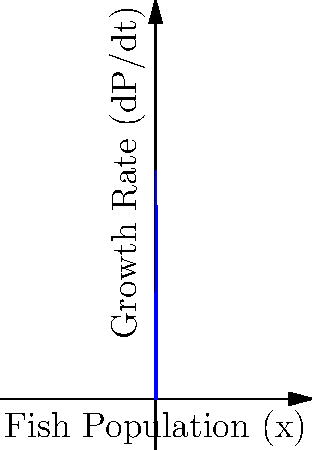A marine ecosystem follows a logistic growth model for its fish population, described by the differential equation:

$$\frac{dP}{dt} = rP(1-\frac{P}{K})$$

where $P$ is the population size, $r$ is the growth rate, and $K$ is the carrying capacity. Given $r = 0.4$ and $K = 5000$, at what population size will the growth rate be maximized? How can this information be used to determine a sustainable fishing quota? To solve this problem, we'll follow these steps:

1) The growth rate (dP/dt) is maximized when the population is at half the carrying capacity. This occurs at the vertex of the parabola in the logistic growth curve.

2) Mathematically, we can find this point by setting $P = \frac{K}{2}$:

   $P = \frac{K}{2} = \frac{5000}{2} = 2500$

3) To verify, we can calculate the second derivative of the growth equation and show it's negative at this point, confirming a maximum:

   $$\frac{d^2P}{dt^2} = r(1-\frac{2P}{K})$$

   When $P = 2500$, this is negative, confirming a maximum.

4) The maximum sustainable yield occurs at this population level. The sustainable fishing quota should be set to the growth rate at this point:

   $$\frac{dP}{dt} = rP(1-\frac{P}{K}) = 0.4 * 2500 * (1-\frac{2500}{5000}) = 500$$

5) Therefore, a sustainable fishing quota would be 500 fish per time unit (e.g., per year), allowing the population to maintain its maximum growth rate.

This approach ensures that the fish population can replenish itself at its maximum rate, balancing conservation with sustainable resource use.
Answer: Maximum growth rate occurs at 2500 fish; sustainable fishing quota is 500 fish per time unit. 